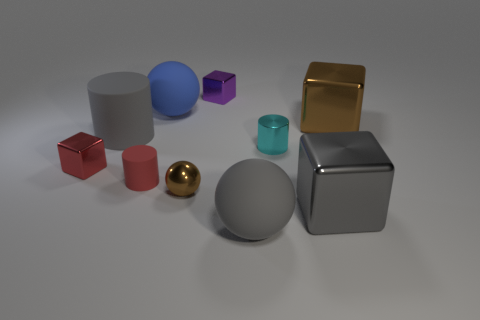What is the size of the red object that is made of the same material as the small brown ball?
Make the answer very short. Small. Is the size of the purple shiny object the same as the red metal cube?
Your answer should be very brief. Yes. Is there a blue object?
Give a very brief answer. Yes. What is the size of the metallic block that is the same color as the tiny ball?
Give a very brief answer. Large. How big is the shiny block on the left side of the big sphere behind the red rubber cylinder that is behind the gray matte ball?
Give a very brief answer. Small. How many purple balls are made of the same material as the gray cylinder?
Your answer should be compact. 0. What number of blue balls have the same size as the purple thing?
Give a very brief answer. 0. There is a gray cube that is on the right side of the red shiny object that is on the left side of the matte ball in front of the small red metal object; what is it made of?
Keep it short and to the point. Metal. How many things are blue shiny objects or gray metallic things?
Give a very brief answer. 1. Is there anything else that has the same material as the gray cylinder?
Your answer should be compact. Yes. 